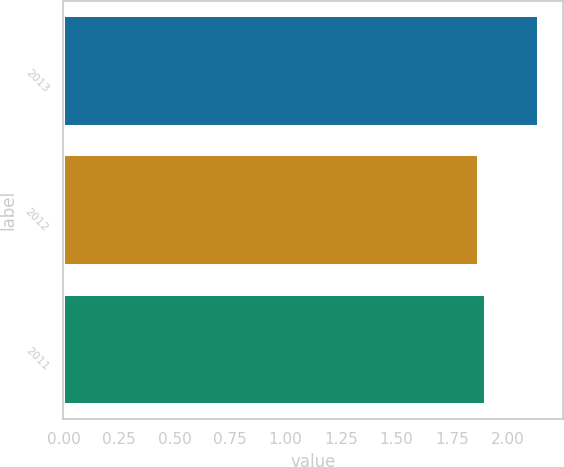<chart> <loc_0><loc_0><loc_500><loc_500><bar_chart><fcel>2013<fcel>2012<fcel>2011<nl><fcel>2.14<fcel>1.87<fcel>1.9<nl></chart> 